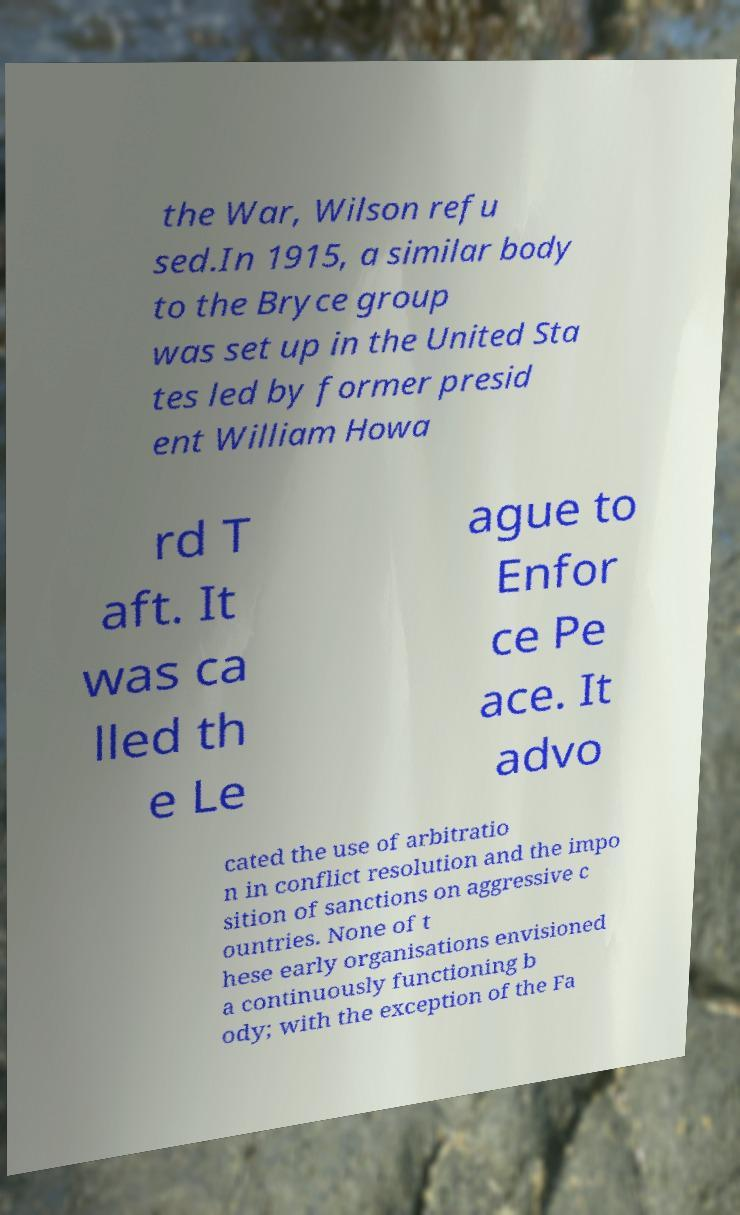Can you read and provide the text displayed in the image?This photo seems to have some interesting text. Can you extract and type it out for me? the War, Wilson refu sed.In 1915, a similar body to the Bryce group was set up in the United Sta tes led by former presid ent William Howa rd T aft. It was ca lled th e Le ague to Enfor ce Pe ace. It advo cated the use of arbitratio n in conflict resolution and the impo sition of sanctions on aggressive c ountries. None of t hese early organisations envisioned a continuously functioning b ody; with the exception of the Fa 